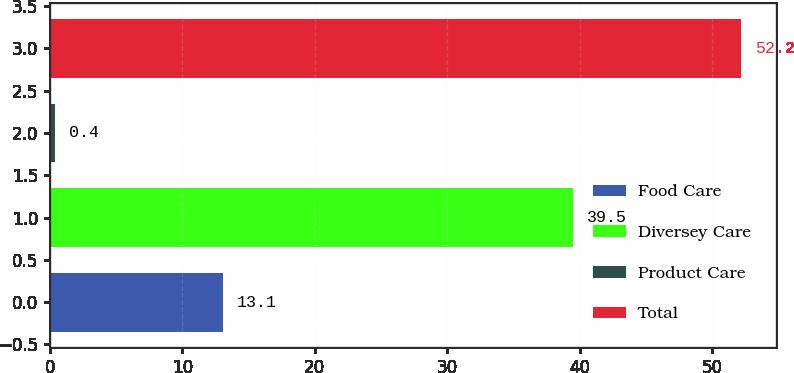Convert chart to OTSL. <chart><loc_0><loc_0><loc_500><loc_500><bar_chart><fcel>Food Care<fcel>Diversey Care<fcel>Product Care<fcel>Total<nl><fcel>13.1<fcel>39.5<fcel>0.4<fcel>52.2<nl></chart> 